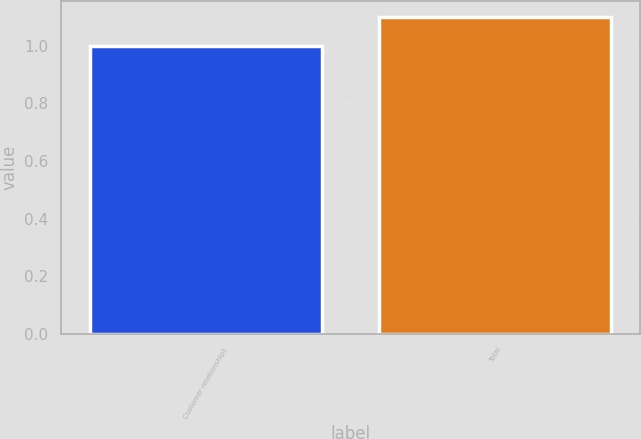Convert chart to OTSL. <chart><loc_0><loc_0><loc_500><loc_500><bar_chart><fcel>Customer relationships<fcel>Total<nl><fcel>1<fcel>1.1<nl></chart> 